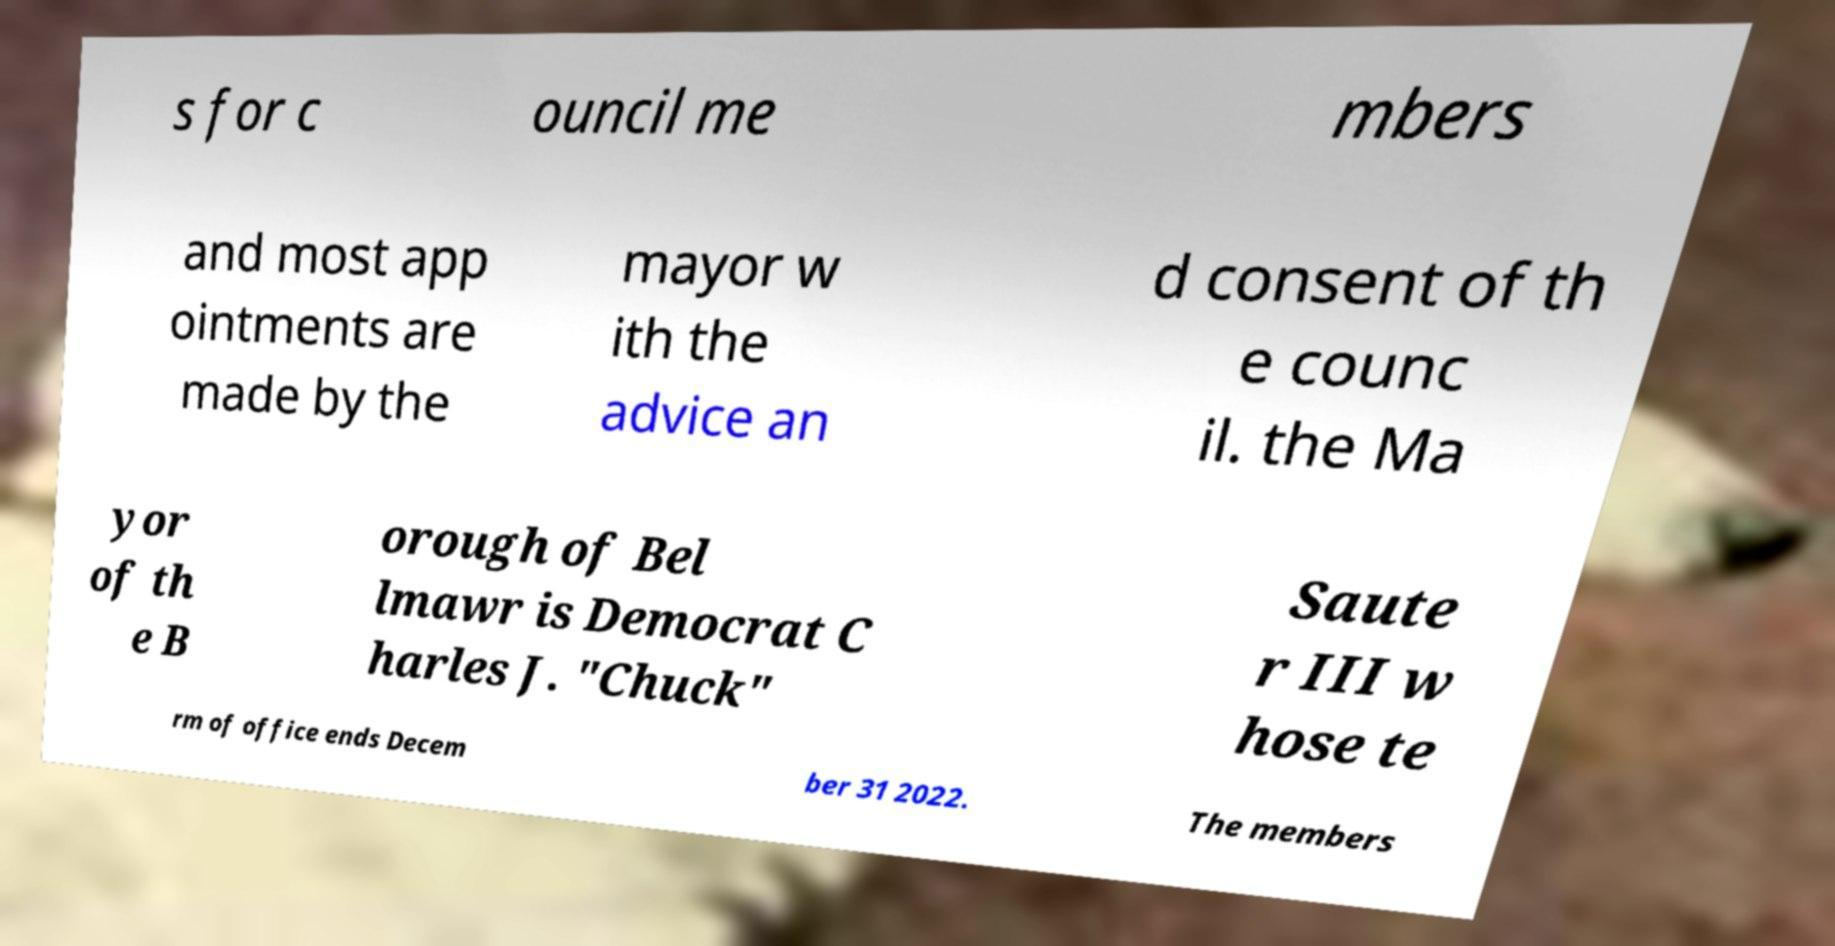Could you extract and type out the text from this image? s for c ouncil me mbers and most app ointments are made by the mayor w ith the advice an d consent of th e counc il. the Ma yor of th e B orough of Bel lmawr is Democrat C harles J. "Chuck" Saute r III w hose te rm of office ends Decem ber 31 2022. The members 